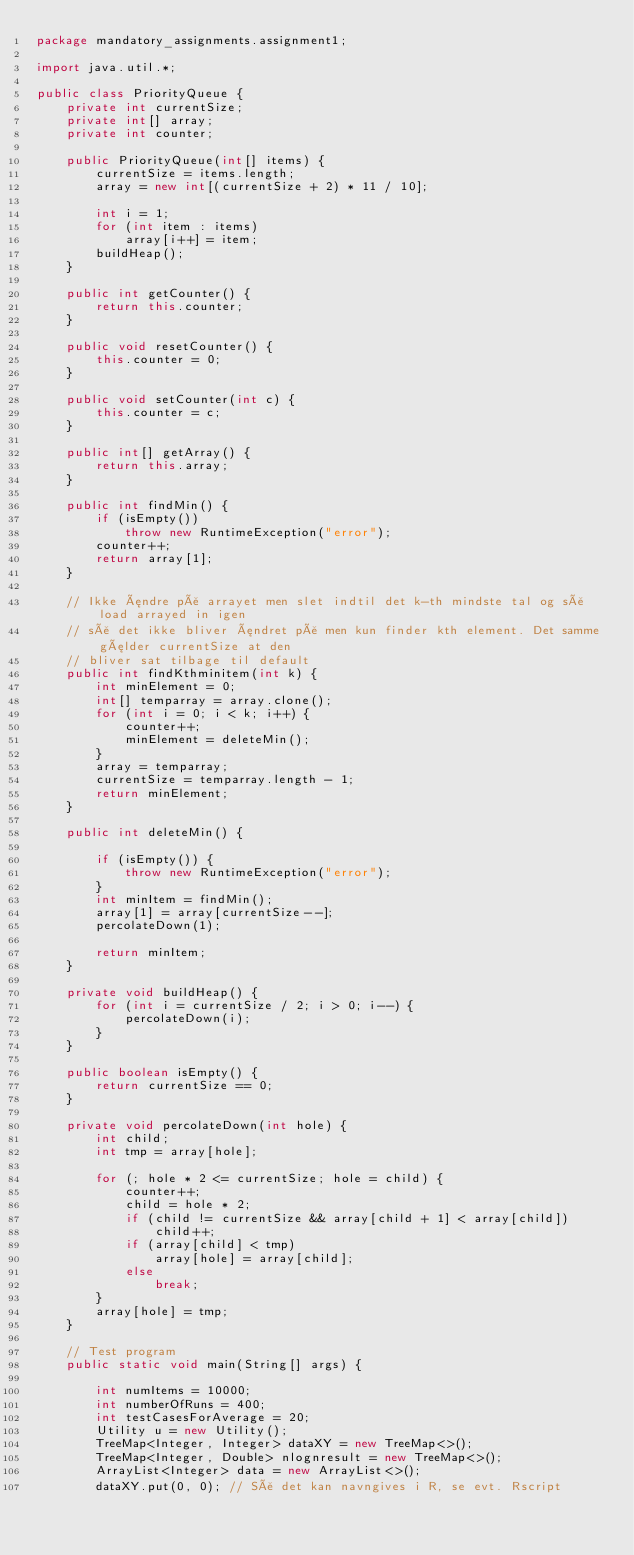<code> <loc_0><loc_0><loc_500><loc_500><_Java_>package mandatory_assignments.assignment1;

import java.util.*;

public class PriorityQueue {
    private int currentSize;
    private int[] array;
    private int counter;

    public PriorityQueue(int[] items) {
        currentSize = items.length;
        array = new int[(currentSize + 2) * 11 / 10];

        int i = 1;
        for (int item : items)
            array[i++] = item;
        buildHeap();
    }

    public int getCounter() {
        return this.counter;
    }

    public void resetCounter() {
        this.counter = 0;
    }

    public void setCounter(int c) {
        this.counter = c;
    }

    public int[] getArray() {
        return this.array;
    }

    public int findMin() {
        if (isEmpty())
            throw new RuntimeException("error");
        counter++;
        return array[1];
    }

    // Ikke ændre på arrayet men slet indtil det k-th mindste tal og så load arrayed in igen
    // så det ikke bliver ændret på men kun finder kth element. Det samme gælder currentSize at den
    // bliver sat tilbage til default
    public int findKthminitem(int k) {
        int minElement = 0;
        int[] temparray = array.clone();
        for (int i = 0; i < k; i++) {
            counter++;
            minElement = deleteMin();
        }
        array = temparray;
        currentSize = temparray.length - 1;
        return minElement;
    }

    public int deleteMin() {

        if (isEmpty()) {
            throw new RuntimeException("error");
        }
        int minItem = findMin();
        array[1] = array[currentSize--];
        percolateDown(1);

        return minItem;
    }

    private void buildHeap() {
        for (int i = currentSize / 2; i > 0; i--) {
            percolateDown(i);
        }
    }

    public boolean isEmpty() {
        return currentSize == 0;
    }

    private void percolateDown(int hole) {
        int child;
        int tmp = array[hole];

        for (; hole * 2 <= currentSize; hole = child) {
            counter++;
            child = hole * 2;
            if (child != currentSize && array[child + 1] < array[child])
                child++;
            if (array[child] < tmp)
                array[hole] = array[child];
            else
                break;
        }
        array[hole] = tmp;
    }

    // Test program
    public static void main(String[] args) {

        int numItems = 10000;
        int numberOfRuns = 400;
        int testCasesForAverage = 20;
        Utility u = new Utility();
        TreeMap<Integer, Integer> dataXY = new TreeMap<>();
        TreeMap<Integer, Double> nlognresult = new TreeMap<>();
        ArrayList<Integer> data = new ArrayList<>();
        dataXY.put(0, 0); // Så det kan navngives i R, se evt. Rscript</code> 